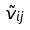Convert formula to latex. <formula><loc_0><loc_0><loc_500><loc_500>\tilde { v } _ { i j }</formula> 